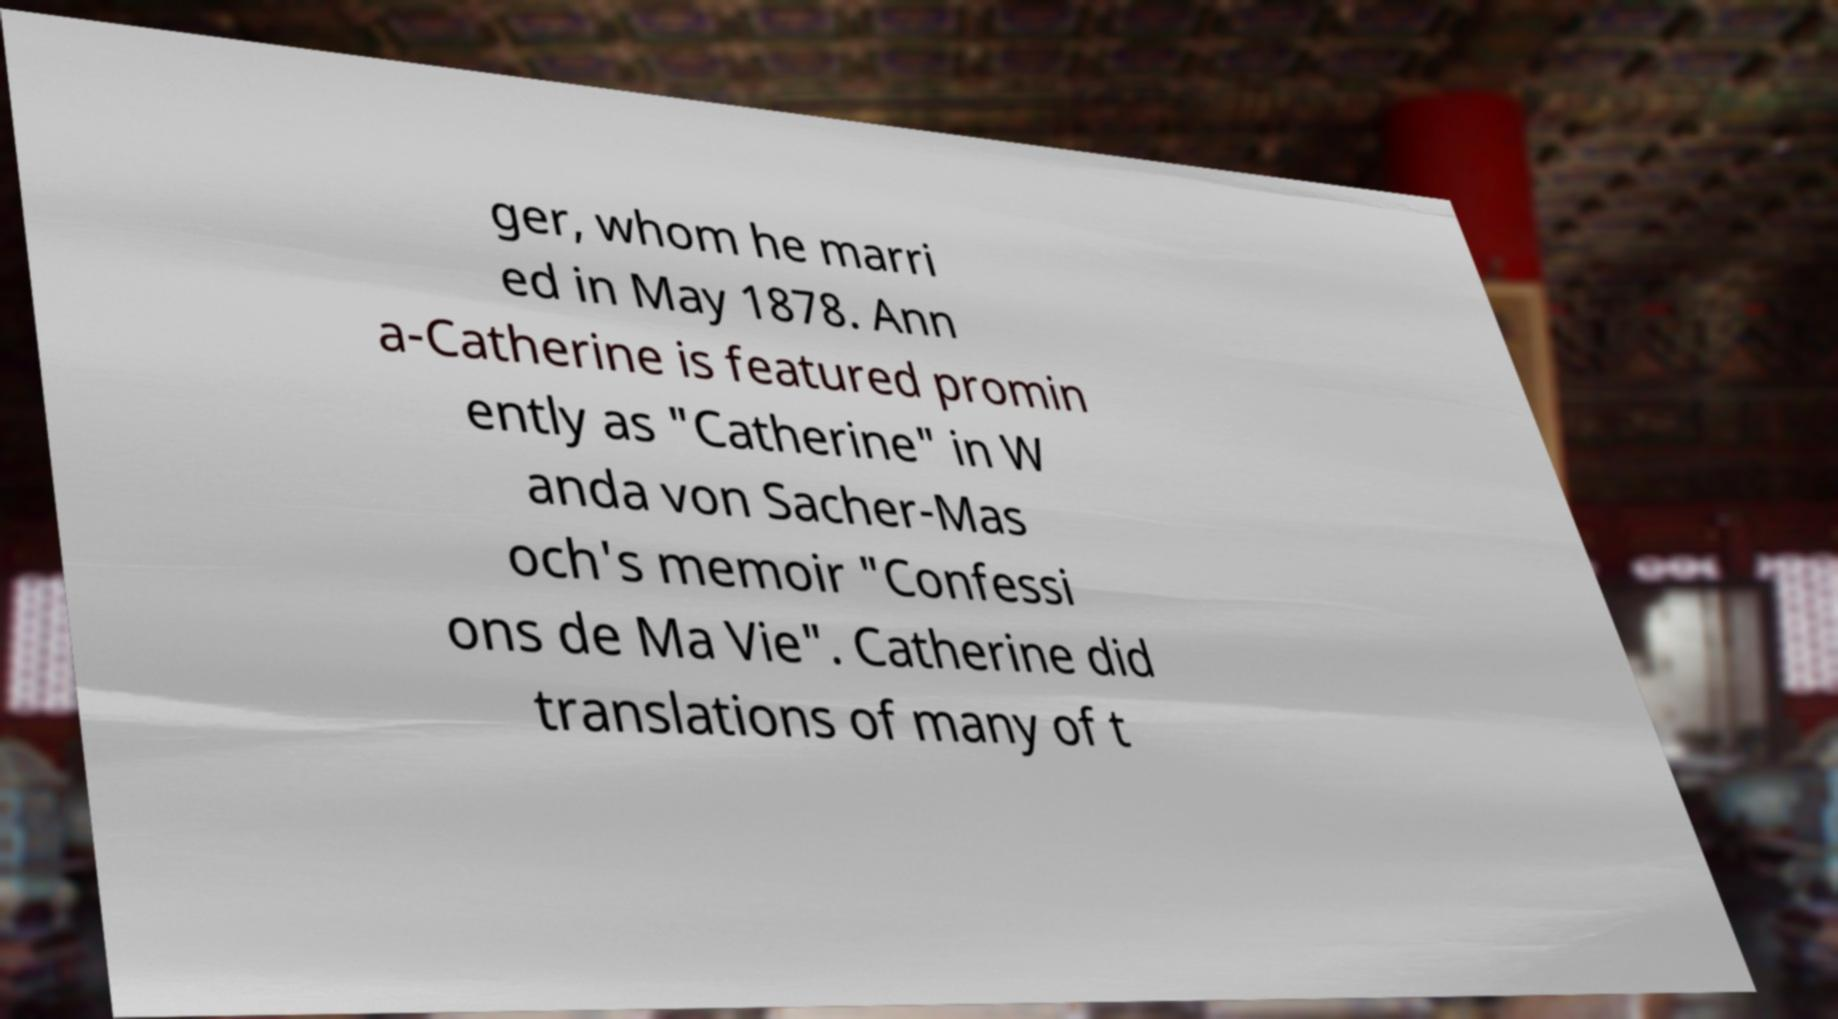Please read and relay the text visible in this image. What does it say? ger, whom he marri ed in May 1878. Ann a-Catherine is featured promin ently as "Catherine" in W anda von Sacher-Mas och's memoir "Confessi ons de Ma Vie". Catherine did translations of many of t 